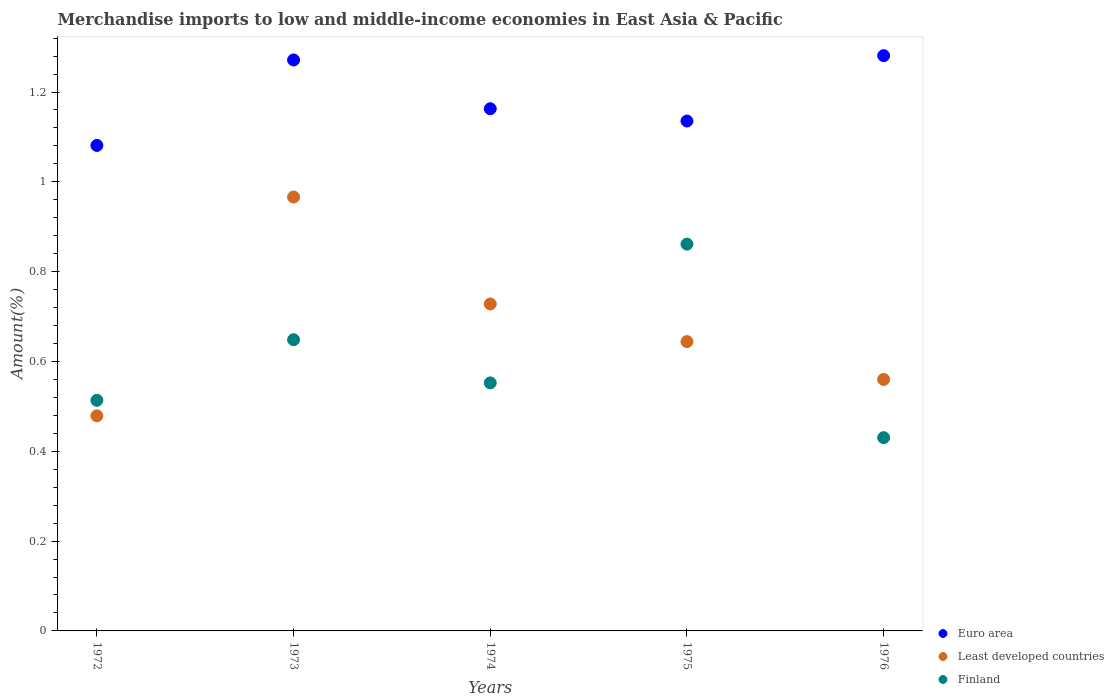How many different coloured dotlines are there?
Provide a succinct answer. 3. Is the number of dotlines equal to the number of legend labels?
Your answer should be very brief. Yes. What is the percentage of amount earned from merchandise imports in Least developed countries in 1975?
Provide a succinct answer. 0.64. Across all years, what is the maximum percentage of amount earned from merchandise imports in Least developed countries?
Offer a terse response. 0.97. Across all years, what is the minimum percentage of amount earned from merchandise imports in Least developed countries?
Your answer should be very brief. 0.48. What is the total percentage of amount earned from merchandise imports in Euro area in the graph?
Your response must be concise. 5.93. What is the difference between the percentage of amount earned from merchandise imports in Finland in 1975 and that in 1976?
Give a very brief answer. 0.43. What is the difference between the percentage of amount earned from merchandise imports in Finland in 1972 and the percentage of amount earned from merchandise imports in Euro area in 1976?
Give a very brief answer. -0.77. What is the average percentage of amount earned from merchandise imports in Euro area per year?
Your answer should be very brief. 1.19. In the year 1974, what is the difference between the percentage of amount earned from merchandise imports in Euro area and percentage of amount earned from merchandise imports in Finland?
Make the answer very short. 0.61. What is the ratio of the percentage of amount earned from merchandise imports in Least developed countries in 1974 to that in 1975?
Ensure brevity in your answer.  1.13. Is the difference between the percentage of amount earned from merchandise imports in Euro area in 1975 and 1976 greater than the difference between the percentage of amount earned from merchandise imports in Finland in 1975 and 1976?
Provide a succinct answer. No. What is the difference between the highest and the second highest percentage of amount earned from merchandise imports in Euro area?
Offer a very short reply. 0.01. What is the difference between the highest and the lowest percentage of amount earned from merchandise imports in Euro area?
Your answer should be compact. 0.2. In how many years, is the percentage of amount earned from merchandise imports in Euro area greater than the average percentage of amount earned from merchandise imports in Euro area taken over all years?
Provide a short and direct response. 2. Is it the case that in every year, the sum of the percentage of amount earned from merchandise imports in Finland and percentage of amount earned from merchandise imports in Euro area  is greater than the percentage of amount earned from merchandise imports in Least developed countries?
Offer a very short reply. Yes. Does the percentage of amount earned from merchandise imports in Euro area monotonically increase over the years?
Make the answer very short. No. Is the percentage of amount earned from merchandise imports in Euro area strictly greater than the percentage of amount earned from merchandise imports in Finland over the years?
Keep it short and to the point. Yes. How many years are there in the graph?
Your response must be concise. 5. Are the values on the major ticks of Y-axis written in scientific E-notation?
Keep it short and to the point. No. Does the graph contain grids?
Provide a short and direct response. No. How many legend labels are there?
Provide a short and direct response. 3. What is the title of the graph?
Offer a very short reply. Merchandise imports to low and middle-income economies in East Asia & Pacific. Does "Lesotho" appear as one of the legend labels in the graph?
Your answer should be very brief. No. What is the label or title of the X-axis?
Offer a terse response. Years. What is the label or title of the Y-axis?
Provide a short and direct response. Amount(%). What is the Amount(%) of Euro area in 1972?
Ensure brevity in your answer.  1.08. What is the Amount(%) in Least developed countries in 1972?
Your answer should be very brief. 0.48. What is the Amount(%) in Finland in 1972?
Provide a short and direct response. 0.51. What is the Amount(%) of Euro area in 1973?
Keep it short and to the point. 1.27. What is the Amount(%) in Least developed countries in 1973?
Ensure brevity in your answer.  0.97. What is the Amount(%) of Finland in 1973?
Offer a terse response. 0.65. What is the Amount(%) of Euro area in 1974?
Provide a short and direct response. 1.16. What is the Amount(%) of Least developed countries in 1974?
Make the answer very short. 0.73. What is the Amount(%) of Finland in 1974?
Ensure brevity in your answer.  0.55. What is the Amount(%) of Euro area in 1975?
Provide a succinct answer. 1.14. What is the Amount(%) in Least developed countries in 1975?
Provide a succinct answer. 0.64. What is the Amount(%) of Finland in 1975?
Make the answer very short. 0.86. What is the Amount(%) of Euro area in 1976?
Ensure brevity in your answer.  1.28. What is the Amount(%) of Least developed countries in 1976?
Keep it short and to the point. 0.56. What is the Amount(%) in Finland in 1976?
Offer a terse response. 0.43. Across all years, what is the maximum Amount(%) of Euro area?
Provide a succinct answer. 1.28. Across all years, what is the maximum Amount(%) in Least developed countries?
Make the answer very short. 0.97. Across all years, what is the maximum Amount(%) of Finland?
Your answer should be very brief. 0.86. Across all years, what is the minimum Amount(%) of Euro area?
Offer a terse response. 1.08. Across all years, what is the minimum Amount(%) of Least developed countries?
Make the answer very short. 0.48. Across all years, what is the minimum Amount(%) in Finland?
Offer a very short reply. 0.43. What is the total Amount(%) in Euro area in the graph?
Your answer should be very brief. 5.93. What is the total Amount(%) of Least developed countries in the graph?
Your answer should be very brief. 3.38. What is the total Amount(%) in Finland in the graph?
Offer a terse response. 3.01. What is the difference between the Amount(%) in Euro area in 1972 and that in 1973?
Give a very brief answer. -0.19. What is the difference between the Amount(%) in Least developed countries in 1972 and that in 1973?
Give a very brief answer. -0.49. What is the difference between the Amount(%) of Finland in 1972 and that in 1973?
Your response must be concise. -0.13. What is the difference between the Amount(%) in Euro area in 1972 and that in 1974?
Ensure brevity in your answer.  -0.08. What is the difference between the Amount(%) of Least developed countries in 1972 and that in 1974?
Provide a short and direct response. -0.25. What is the difference between the Amount(%) of Finland in 1972 and that in 1974?
Provide a succinct answer. -0.04. What is the difference between the Amount(%) in Euro area in 1972 and that in 1975?
Offer a terse response. -0.05. What is the difference between the Amount(%) of Least developed countries in 1972 and that in 1975?
Give a very brief answer. -0.17. What is the difference between the Amount(%) in Finland in 1972 and that in 1975?
Your answer should be very brief. -0.35. What is the difference between the Amount(%) of Euro area in 1972 and that in 1976?
Offer a very short reply. -0.2. What is the difference between the Amount(%) in Least developed countries in 1972 and that in 1976?
Your answer should be compact. -0.08. What is the difference between the Amount(%) in Finland in 1972 and that in 1976?
Make the answer very short. 0.08. What is the difference between the Amount(%) in Euro area in 1973 and that in 1974?
Offer a terse response. 0.11. What is the difference between the Amount(%) of Least developed countries in 1973 and that in 1974?
Provide a succinct answer. 0.24. What is the difference between the Amount(%) in Finland in 1973 and that in 1974?
Keep it short and to the point. 0.1. What is the difference between the Amount(%) in Euro area in 1973 and that in 1975?
Offer a terse response. 0.14. What is the difference between the Amount(%) of Least developed countries in 1973 and that in 1975?
Offer a terse response. 0.32. What is the difference between the Amount(%) in Finland in 1973 and that in 1975?
Your answer should be compact. -0.21. What is the difference between the Amount(%) in Euro area in 1973 and that in 1976?
Provide a short and direct response. -0.01. What is the difference between the Amount(%) of Least developed countries in 1973 and that in 1976?
Your response must be concise. 0.41. What is the difference between the Amount(%) of Finland in 1973 and that in 1976?
Ensure brevity in your answer.  0.22. What is the difference between the Amount(%) of Euro area in 1974 and that in 1975?
Your response must be concise. 0.03. What is the difference between the Amount(%) of Least developed countries in 1974 and that in 1975?
Your response must be concise. 0.08. What is the difference between the Amount(%) in Finland in 1974 and that in 1975?
Provide a succinct answer. -0.31. What is the difference between the Amount(%) in Euro area in 1974 and that in 1976?
Ensure brevity in your answer.  -0.12. What is the difference between the Amount(%) in Least developed countries in 1974 and that in 1976?
Provide a succinct answer. 0.17. What is the difference between the Amount(%) in Finland in 1974 and that in 1976?
Ensure brevity in your answer.  0.12. What is the difference between the Amount(%) in Euro area in 1975 and that in 1976?
Provide a short and direct response. -0.15. What is the difference between the Amount(%) of Least developed countries in 1975 and that in 1976?
Ensure brevity in your answer.  0.08. What is the difference between the Amount(%) in Finland in 1975 and that in 1976?
Give a very brief answer. 0.43. What is the difference between the Amount(%) of Euro area in 1972 and the Amount(%) of Least developed countries in 1973?
Give a very brief answer. 0.11. What is the difference between the Amount(%) in Euro area in 1972 and the Amount(%) in Finland in 1973?
Provide a short and direct response. 0.43. What is the difference between the Amount(%) of Least developed countries in 1972 and the Amount(%) of Finland in 1973?
Make the answer very short. -0.17. What is the difference between the Amount(%) in Euro area in 1972 and the Amount(%) in Least developed countries in 1974?
Your answer should be compact. 0.35. What is the difference between the Amount(%) in Euro area in 1972 and the Amount(%) in Finland in 1974?
Your answer should be very brief. 0.53. What is the difference between the Amount(%) in Least developed countries in 1972 and the Amount(%) in Finland in 1974?
Keep it short and to the point. -0.07. What is the difference between the Amount(%) of Euro area in 1972 and the Amount(%) of Least developed countries in 1975?
Keep it short and to the point. 0.44. What is the difference between the Amount(%) in Euro area in 1972 and the Amount(%) in Finland in 1975?
Provide a succinct answer. 0.22. What is the difference between the Amount(%) of Least developed countries in 1972 and the Amount(%) of Finland in 1975?
Give a very brief answer. -0.38. What is the difference between the Amount(%) of Euro area in 1972 and the Amount(%) of Least developed countries in 1976?
Your answer should be compact. 0.52. What is the difference between the Amount(%) of Euro area in 1972 and the Amount(%) of Finland in 1976?
Ensure brevity in your answer.  0.65. What is the difference between the Amount(%) in Least developed countries in 1972 and the Amount(%) in Finland in 1976?
Offer a terse response. 0.05. What is the difference between the Amount(%) of Euro area in 1973 and the Amount(%) of Least developed countries in 1974?
Provide a succinct answer. 0.54. What is the difference between the Amount(%) of Euro area in 1973 and the Amount(%) of Finland in 1974?
Provide a succinct answer. 0.72. What is the difference between the Amount(%) of Least developed countries in 1973 and the Amount(%) of Finland in 1974?
Your answer should be very brief. 0.41. What is the difference between the Amount(%) of Euro area in 1973 and the Amount(%) of Least developed countries in 1975?
Your answer should be very brief. 0.63. What is the difference between the Amount(%) of Euro area in 1973 and the Amount(%) of Finland in 1975?
Ensure brevity in your answer.  0.41. What is the difference between the Amount(%) in Least developed countries in 1973 and the Amount(%) in Finland in 1975?
Provide a succinct answer. 0.1. What is the difference between the Amount(%) of Euro area in 1973 and the Amount(%) of Least developed countries in 1976?
Offer a terse response. 0.71. What is the difference between the Amount(%) of Euro area in 1973 and the Amount(%) of Finland in 1976?
Keep it short and to the point. 0.84. What is the difference between the Amount(%) in Least developed countries in 1973 and the Amount(%) in Finland in 1976?
Offer a very short reply. 0.54. What is the difference between the Amount(%) in Euro area in 1974 and the Amount(%) in Least developed countries in 1975?
Provide a succinct answer. 0.52. What is the difference between the Amount(%) of Euro area in 1974 and the Amount(%) of Finland in 1975?
Ensure brevity in your answer.  0.3. What is the difference between the Amount(%) in Least developed countries in 1974 and the Amount(%) in Finland in 1975?
Offer a terse response. -0.13. What is the difference between the Amount(%) of Euro area in 1974 and the Amount(%) of Least developed countries in 1976?
Keep it short and to the point. 0.6. What is the difference between the Amount(%) in Euro area in 1974 and the Amount(%) in Finland in 1976?
Ensure brevity in your answer.  0.73. What is the difference between the Amount(%) of Least developed countries in 1974 and the Amount(%) of Finland in 1976?
Offer a terse response. 0.3. What is the difference between the Amount(%) in Euro area in 1975 and the Amount(%) in Least developed countries in 1976?
Offer a very short reply. 0.58. What is the difference between the Amount(%) of Euro area in 1975 and the Amount(%) of Finland in 1976?
Keep it short and to the point. 0.7. What is the difference between the Amount(%) of Least developed countries in 1975 and the Amount(%) of Finland in 1976?
Make the answer very short. 0.21. What is the average Amount(%) in Euro area per year?
Offer a terse response. 1.19. What is the average Amount(%) of Least developed countries per year?
Your response must be concise. 0.68. What is the average Amount(%) of Finland per year?
Your response must be concise. 0.6. In the year 1972, what is the difference between the Amount(%) in Euro area and Amount(%) in Least developed countries?
Provide a short and direct response. 0.6. In the year 1972, what is the difference between the Amount(%) in Euro area and Amount(%) in Finland?
Offer a very short reply. 0.57. In the year 1972, what is the difference between the Amount(%) in Least developed countries and Amount(%) in Finland?
Give a very brief answer. -0.03. In the year 1973, what is the difference between the Amount(%) of Euro area and Amount(%) of Least developed countries?
Offer a terse response. 0.31. In the year 1973, what is the difference between the Amount(%) of Euro area and Amount(%) of Finland?
Keep it short and to the point. 0.62. In the year 1973, what is the difference between the Amount(%) in Least developed countries and Amount(%) in Finland?
Offer a terse response. 0.32. In the year 1974, what is the difference between the Amount(%) of Euro area and Amount(%) of Least developed countries?
Provide a short and direct response. 0.43. In the year 1974, what is the difference between the Amount(%) in Euro area and Amount(%) in Finland?
Your answer should be very brief. 0.61. In the year 1974, what is the difference between the Amount(%) in Least developed countries and Amount(%) in Finland?
Give a very brief answer. 0.18. In the year 1975, what is the difference between the Amount(%) in Euro area and Amount(%) in Least developed countries?
Your answer should be compact. 0.49. In the year 1975, what is the difference between the Amount(%) of Euro area and Amount(%) of Finland?
Offer a very short reply. 0.27. In the year 1975, what is the difference between the Amount(%) of Least developed countries and Amount(%) of Finland?
Keep it short and to the point. -0.22. In the year 1976, what is the difference between the Amount(%) in Euro area and Amount(%) in Least developed countries?
Your answer should be compact. 0.72. In the year 1976, what is the difference between the Amount(%) of Euro area and Amount(%) of Finland?
Your response must be concise. 0.85. In the year 1976, what is the difference between the Amount(%) of Least developed countries and Amount(%) of Finland?
Your answer should be very brief. 0.13. What is the ratio of the Amount(%) of Euro area in 1972 to that in 1973?
Make the answer very short. 0.85. What is the ratio of the Amount(%) in Least developed countries in 1972 to that in 1973?
Offer a very short reply. 0.5. What is the ratio of the Amount(%) in Finland in 1972 to that in 1973?
Make the answer very short. 0.79. What is the ratio of the Amount(%) of Euro area in 1972 to that in 1974?
Make the answer very short. 0.93. What is the ratio of the Amount(%) in Least developed countries in 1972 to that in 1974?
Make the answer very short. 0.66. What is the ratio of the Amount(%) in Finland in 1972 to that in 1974?
Your answer should be very brief. 0.93. What is the ratio of the Amount(%) of Euro area in 1972 to that in 1975?
Offer a terse response. 0.95. What is the ratio of the Amount(%) of Least developed countries in 1972 to that in 1975?
Your response must be concise. 0.74. What is the ratio of the Amount(%) in Finland in 1972 to that in 1975?
Keep it short and to the point. 0.6. What is the ratio of the Amount(%) in Euro area in 1972 to that in 1976?
Keep it short and to the point. 0.84. What is the ratio of the Amount(%) of Least developed countries in 1972 to that in 1976?
Ensure brevity in your answer.  0.86. What is the ratio of the Amount(%) in Finland in 1972 to that in 1976?
Provide a succinct answer. 1.19. What is the ratio of the Amount(%) in Euro area in 1973 to that in 1974?
Ensure brevity in your answer.  1.09. What is the ratio of the Amount(%) of Least developed countries in 1973 to that in 1974?
Your answer should be very brief. 1.33. What is the ratio of the Amount(%) in Finland in 1973 to that in 1974?
Give a very brief answer. 1.17. What is the ratio of the Amount(%) of Euro area in 1973 to that in 1975?
Your answer should be very brief. 1.12. What is the ratio of the Amount(%) in Least developed countries in 1973 to that in 1975?
Your answer should be very brief. 1.5. What is the ratio of the Amount(%) in Finland in 1973 to that in 1975?
Offer a terse response. 0.75. What is the ratio of the Amount(%) in Euro area in 1973 to that in 1976?
Make the answer very short. 0.99. What is the ratio of the Amount(%) of Least developed countries in 1973 to that in 1976?
Keep it short and to the point. 1.73. What is the ratio of the Amount(%) of Finland in 1973 to that in 1976?
Provide a succinct answer. 1.51. What is the ratio of the Amount(%) in Euro area in 1974 to that in 1975?
Offer a terse response. 1.02. What is the ratio of the Amount(%) of Least developed countries in 1974 to that in 1975?
Give a very brief answer. 1.13. What is the ratio of the Amount(%) in Finland in 1974 to that in 1975?
Provide a succinct answer. 0.64. What is the ratio of the Amount(%) in Euro area in 1974 to that in 1976?
Keep it short and to the point. 0.91. What is the ratio of the Amount(%) in Finland in 1974 to that in 1976?
Offer a very short reply. 1.28. What is the ratio of the Amount(%) in Euro area in 1975 to that in 1976?
Provide a short and direct response. 0.89. What is the ratio of the Amount(%) in Least developed countries in 1975 to that in 1976?
Keep it short and to the point. 1.15. What is the ratio of the Amount(%) in Finland in 1975 to that in 1976?
Ensure brevity in your answer.  2. What is the difference between the highest and the second highest Amount(%) of Euro area?
Your answer should be compact. 0.01. What is the difference between the highest and the second highest Amount(%) of Least developed countries?
Offer a terse response. 0.24. What is the difference between the highest and the second highest Amount(%) in Finland?
Your response must be concise. 0.21. What is the difference between the highest and the lowest Amount(%) of Euro area?
Your response must be concise. 0.2. What is the difference between the highest and the lowest Amount(%) of Least developed countries?
Make the answer very short. 0.49. What is the difference between the highest and the lowest Amount(%) in Finland?
Your response must be concise. 0.43. 